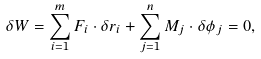<formula> <loc_0><loc_0><loc_500><loc_500>\delta W = \sum _ { i = 1 } ^ { m } F _ { i } \cdot \delta r _ { i } + \sum _ { j = 1 } ^ { n } M _ { j } \cdot \delta \phi _ { j } = 0 ,</formula> 